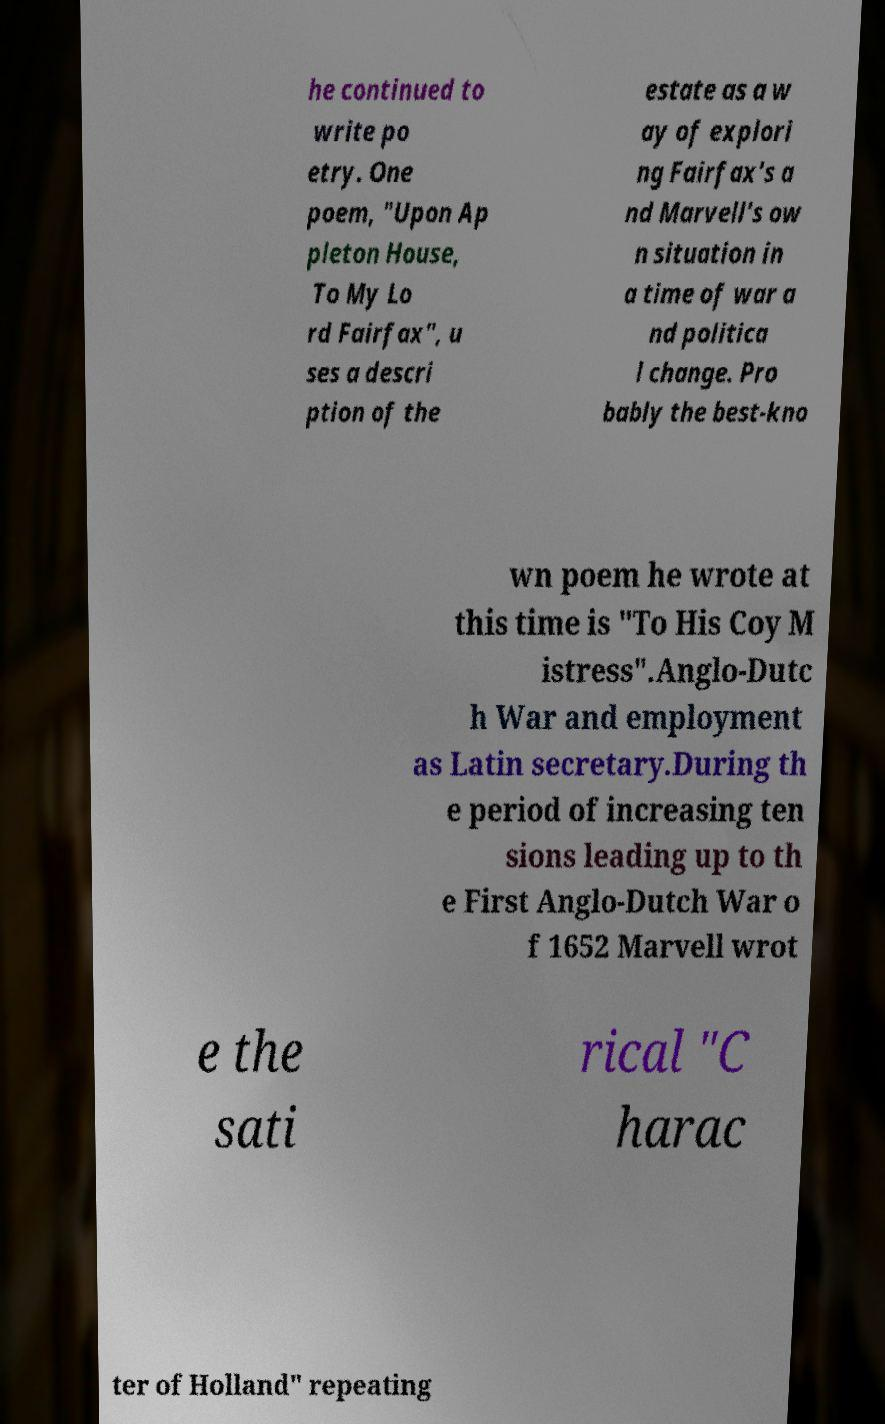Can you accurately transcribe the text from the provided image for me? he continued to write po etry. One poem, "Upon Ap pleton House, To My Lo rd Fairfax", u ses a descri ption of the estate as a w ay of explori ng Fairfax's a nd Marvell's ow n situation in a time of war a nd politica l change. Pro bably the best-kno wn poem he wrote at this time is "To His Coy M istress".Anglo-Dutc h War and employment as Latin secretary.During th e period of increasing ten sions leading up to th e First Anglo-Dutch War o f 1652 Marvell wrot e the sati rical "C harac ter of Holland" repeating 